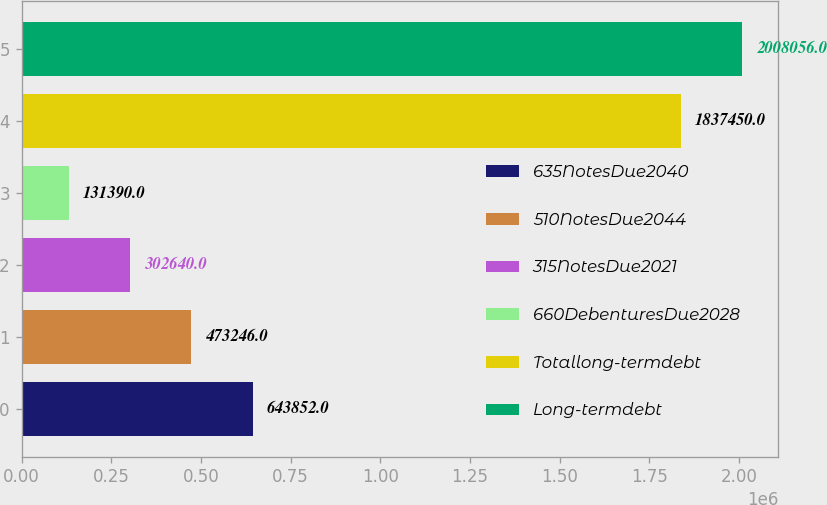Convert chart. <chart><loc_0><loc_0><loc_500><loc_500><bar_chart><fcel>635NotesDue2040<fcel>510NotesDue2044<fcel>315NotesDue2021<fcel>660DebenturesDue2028<fcel>Totallong-termdebt<fcel>Long-termdebt<nl><fcel>643852<fcel>473246<fcel>302640<fcel>131390<fcel>1.83745e+06<fcel>2.00806e+06<nl></chart> 